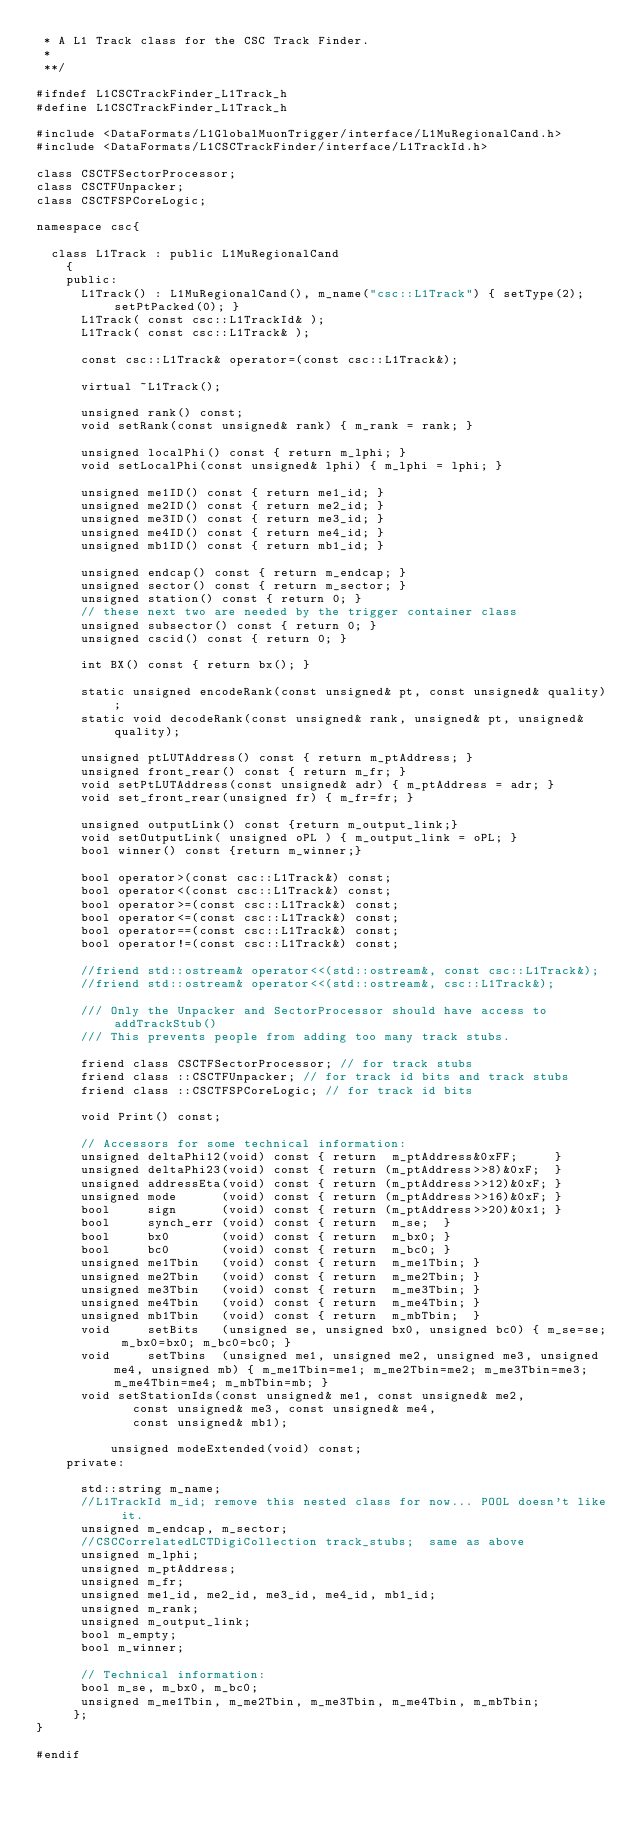Convert code to text. <code><loc_0><loc_0><loc_500><loc_500><_C_> * A L1 Track class for the CSC Track Finder.
 *
 **/

#ifndef L1CSCTrackFinder_L1Track_h
#define L1CSCTrackFinder_L1Track_h

#include <DataFormats/L1GlobalMuonTrigger/interface/L1MuRegionalCand.h>
#include <DataFormats/L1CSCTrackFinder/interface/L1TrackId.h>

class CSCTFSectorProcessor;
class CSCTFUnpacker;
class CSCTFSPCoreLogic;

namespace csc{

  class L1Track : public L1MuRegionalCand
    {
    public:
      L1Track() : L1MuRegionalCand(), m_name("csc::L1Track") { setType(2); setPtPacked(0); }
      L1Track( const csc::L1TrackId& );
      L1Track( const csc::L1Track& );

      const csc::L1Track& operator=(const csc::L1Track&);

      virtual ~L1Track();

      unsigned rank() const;
      void setRank(const unsigned& rank) { m_rank = rank; }

      unsigned localPhi() const { return m_lphi; }
      void setLocalPhi(const unsigned& lphi) { m_lphi = lphi; }

      unsigned me1ID() const { return me1_id; }
      unsigned me2ID() const { return me2_id; }
      unsigned me3ID() const { return me3_id; }
      unsigned me4ID() const { return me4_id; }
      unsigned mb1ID() const { return mb1_id; }

      unsigned endcap() const { return m_endcap; }
      unsigned sector() const { return m_sector; }
      unsigned station() const { return 0; }
      // these next two are needed by the trigger container class
      unsigned subsector() const { return 0; }
      unsigned cscid() const { return 0; }

      int BX() const { return bx(); }

      static unsigned encodeRank(const unsigned& pt, const unsigned& quality);
      static void decodeRank(const unsigned& rank, unsigned& pt, unsigned& quality);

      unsigned ptLUTAddress() const { return m_ptAddress; }
      unsigned front_rear() const { return m_fr; }
      void setPtLUTAddress(const unsigned& adr) { m_ptAddress = adr; }
      void set_front_rear(unsigned fr) { m_fr=fr; }

      unsigned outputLink() const {return m_output_link;}
      void setOutputLink( unsigned oPL ) { m_output_link = oPL; }
      bool winner() const {return m_winner;}

      bool operator>(const csc::L1Track&) const;
      bool operator<(const csc::L1Track&) const;
      bool operator>=(const csc::L1Track&) const;
      bool operator<=(const csc::L1Track&) const;
      bool operator==(const csc::L1Track&) const;
      bool operator!=(const csc::L1Track&) const;

      //friend std::ostream& operator<<(std::ostream&, const csc::L1Track&);
      //friend std::ostream& operator<<(std::ostream&, csc::L1Track&);

      /// Only the Unpacker and SectorProcessor should have access to addTrackStub()
      /// This prevents people from adding too many track stubs.

      friend class CSCTFSectorProcessor; // for track stubs
      friend class ::CSCTFUnpacker; // for track id bits and track stubs
      friend class ::CSCTFSPCoreLogic; // for track id bits

      void Print() const;

	  // Accessors for some technical information:
	  unsigned deltaPhi12(void) const { return  m_ptAddress&0xFF;     }
	  unsigned deltaPhi23(void) const { return (m_ptAddress>>8)&0xF;  }
	  unsigned addressEta(void) const { return (m_ptAddress>>12)&0xF; }
	  unsigned mode      (void) const { return (m_ptAddress>>16)&0xF; }
	  bool     sign      (void) const { return (m_ptAddress>>20)&0x1; }
	  bool     synch_err (void) const { return  m_se;  }
	  bool     bx0       (void) const { return  m_bx0; }
	  bool     bc0       (void) const { return  m_bc0; }
	  unsigned me1Tbin   (void) const { return  m_me1Tbin; }
	  unsigned me2Tbin   (void) const { return  m_me2Tbin; }
	  unsigned me3Tbin   (void) const { return  m_me3Tbin; }
	  unsigned me4Tbin   (void) const { return  m_me4Tbin; }
	  unsigned mb1Tbin   (void) const { return  m_mbTbin;  }
	  void     setBits   (unsigned se, unsigned bx0, unsigned bc0) { m_se=se; m_bx0=bx0; m_bc0=bc0; }
	  void     setTbins  (unsigned me1, unsigned me2, unsigned me3, unsigned me4, unsigned mb) { m_me1Tbin=me1; m_me2Tbin=me2; m_me3Tbin=me3; m_me4Tbin=me4; m_mbTbin=mb; }
	  void setStationIds(const unsigned& me1, const unsigned& me2,
			 const unsigned& me3, const unsigned& me4,
			 const unsigned& mb1);

          unsigned modeExtended(void) const;
    private:

      std::string m_name;
      //L1TrackId m_id; remove this nested class for now... POOL doesn't like it.
      unsigned m_endcap, m_sector;
      //CSCCorrelatedLCTDigiCollection track_stubs;  same as above
      unsigned m_lphi;
      unsigned m_ptAddress;
      unsigned m_fr;
      unsigned me1_id, me2_id, me3_id, me4_id, mb1_id;
      unsigned m_rank;
      unsigned m_output_link;
      bool m_empty;
      bool m_winner;

	  // Technical information:
	  bool m_se, m_bx0, m_bc0;
	  unsigned m_me1Tbin, m_me2Tbin, m_me3Tbin, m_me4Tbin, m_mbTbin;
     };
}

#endif
</code> 